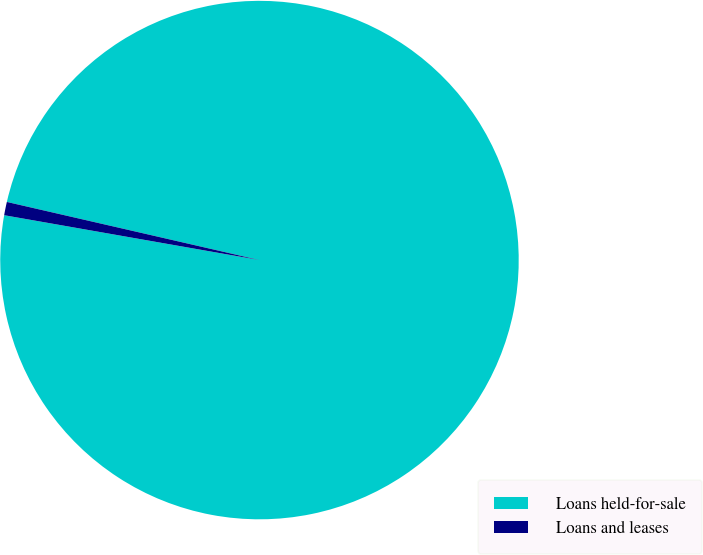<chart> <loc_0><loc_0><loc_500><loc_500><pie_chart><fcel>Loans held-for-sale<fcel>Loans and leases<nl><fcel>99.17%<fcel>0.83%<nl></chart> 